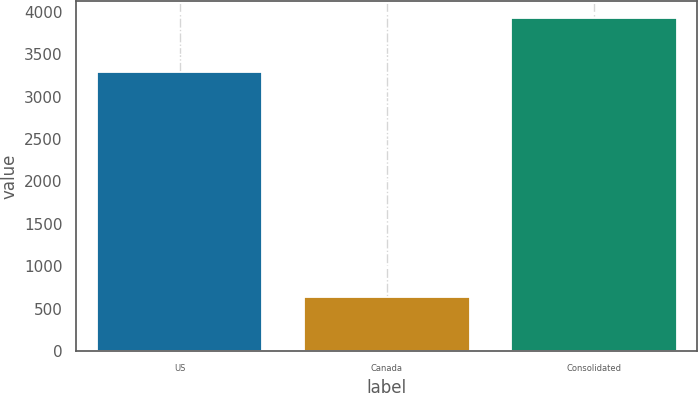Convert chart. <chart><loc_0><loc_0><loc_500><loc_500><bar_chart><fcel>US<fcel>Canada<fcel>Consolidated<nl><fcel>3283.5<fcel>642.1<fcel>3925.6<nl></chart> 